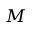<formula> <loc_0><loc_0><loc_500><loc_500>M</formula> 